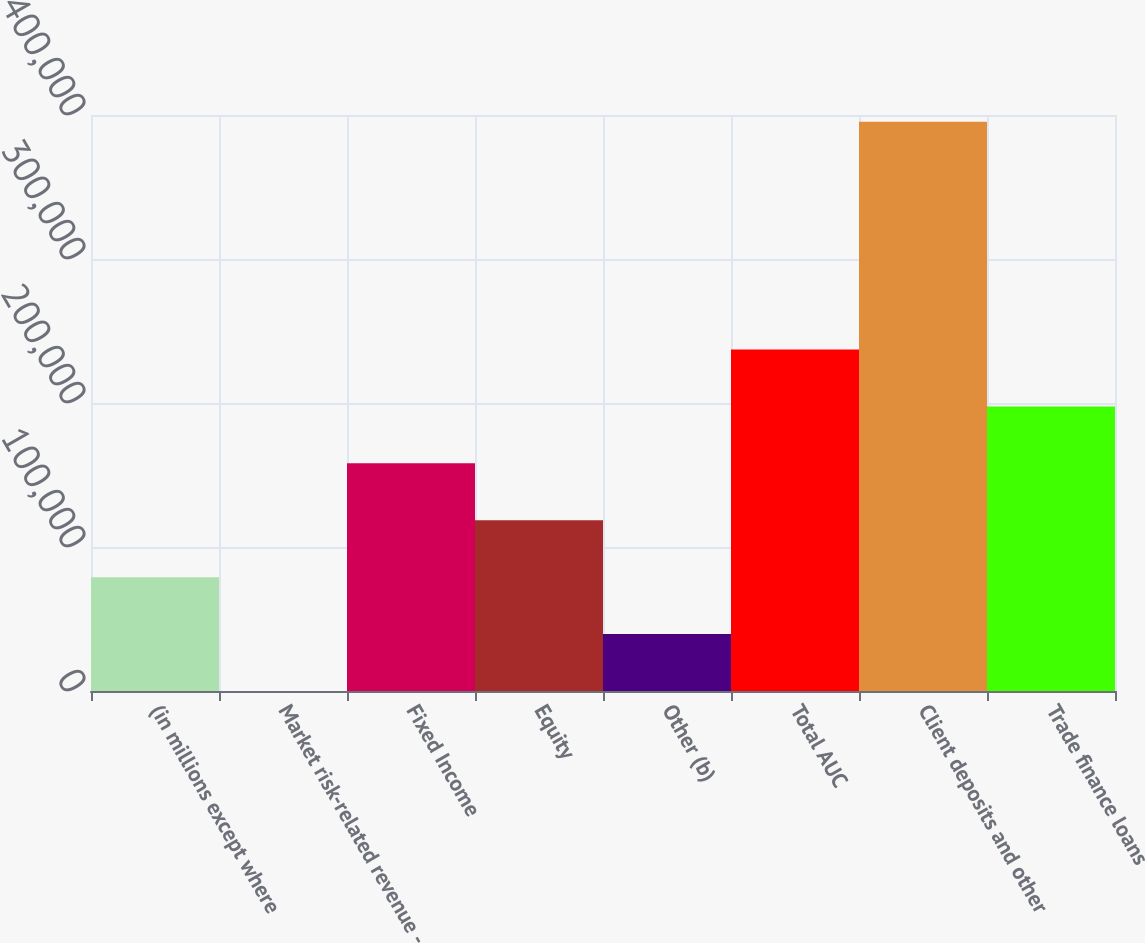Convert chart to OTSL. <chart><loc_0><loc_0><loc_500><loc_500><bar_chart><fcel>(in millions except where<fcel>Market risk-related revenue -<fcel>Fixed Income<fcel>Equity<fcel>Other (b)<fcel>Total AUC<fcel>Client deposits and other<fcel>Trade finance loans<nl><fcel>79066.6<fcel>9<fcel>158124<fcel>118595<fcel>39537.8<fcel>237182<fcel>395297<fcel>197653<nl></chart> 